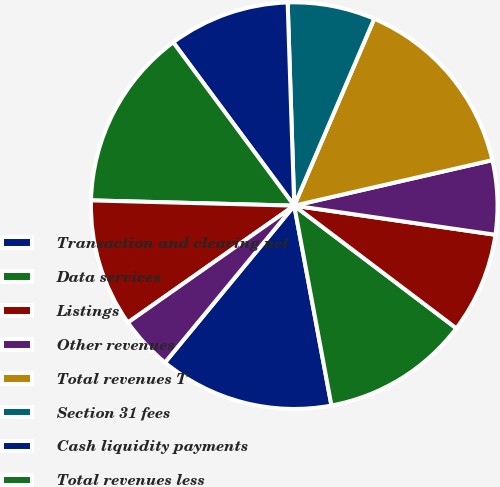<chart> <loc_0><loc_0><loc_500><loc_500><pie_chart><fcel>Transaction and clearing net<fcel>Data services<fcel>Listings<fcel>Other revenues<fcel>Total revenues T<fcel>Section 31 fees<fcel>Cash liquidity payments<fcel>Total revenues less<fcel>Compensation and benefits<fcel>Professional services<nl><fcel>13.9%<fcel>11.76%<fcel>8.02%<fcel>5.88%<fcel>14.97%<fcel>6.95%<fcel>9.63%<fcel>14.44%<fcel>10.16%<fcel>4.28%<nl></chart> 